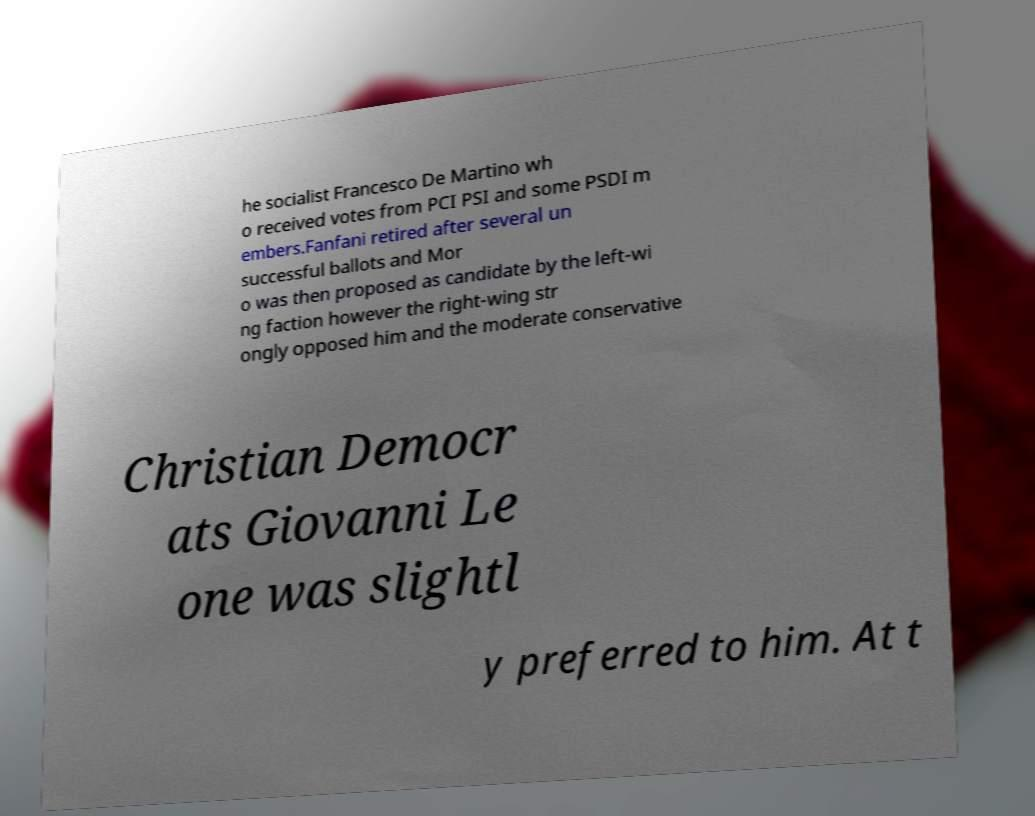I need the written content from this picture converted into text. Can you do that? he socialist Francesco De Martino wh o received votes from PCI PSI and some PSDI m embers.Fanfani retired after several un successful ballots and Mor o was then proposed as candidate by the left-wi ng faction however the right-wing str ongly opposed him and the moderate conservative Christian Democr ats Giovanni Le one was slightl y preferred to him. At t 